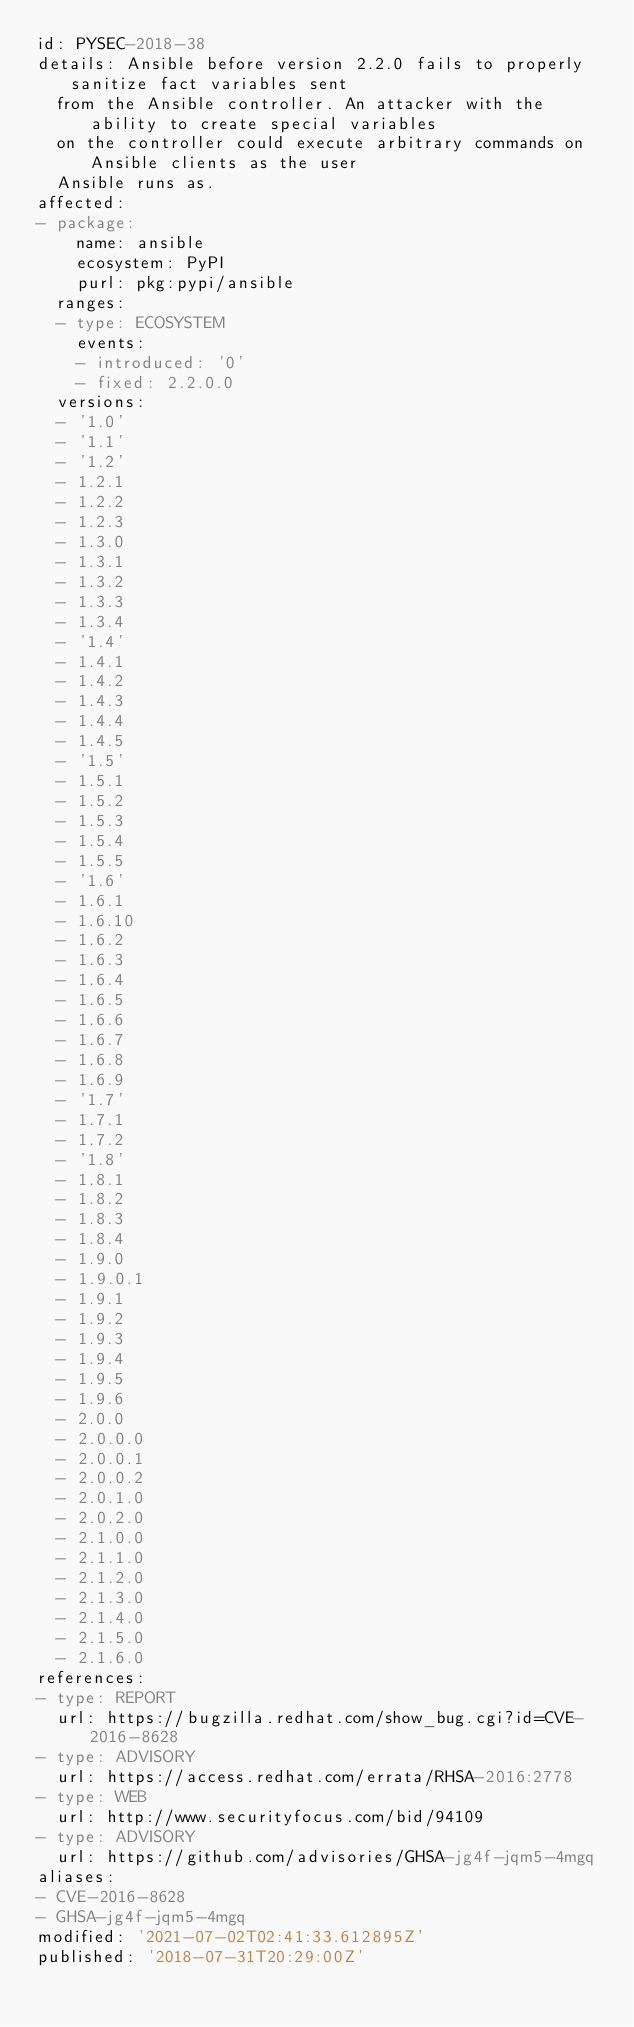<code> <loc_0><loc_0><loc_500><loc_500><_YAML_>id: PYSEC-2018-38
details: Ansible before version 2.2.0 fails to properly sanitize fact variables sent
  from the Ansible controller. An attacker with the ability to create special variables
  on the controller could execute arbitrary commands on Ansible clients as the user
  Ansible runs as.
affected:
- package:
    name: ansible
    ecosystem: PyPI
    purl: pkg:pypi/ansible
  ranges:
  - type: ECOSYSTEM
    events:
    - introduced: '0'
    - fixed: 2.2.0.0
  versions:
  - '1.0'
  - '1.1'
  - '1.2'
  - 1.2.1
  - 1.2.2
  - 1.2.3
  - 1.3.0
  - 1.3.1
  - 1.3.2
  - 1.3.3
  - 1.3.4
  - '1.4'
  - 1.4.1
  - 1.4.2
  - 1.4.3
  - 1.4.4
  - 1.4.5
  - '1.5'
  - 1.5.1
  - 1.5.2
  - 1.5.3
  - 1.5.4
  - 1.5.5
  - '1.6'
  - 1.6.1
  - 1.6.10
  - 1.6.2
  - 1.6.3
  - 1.6.4
  - 1.6.5
  - 1.6.6
  - 1.6.7
  - 1.6.8
  - 1.6.9
  - '1.7'
  - 1.7.1
  - 1.7.2
  - '1.8'
  - 1.8.1
  - 1.8.2
  - 1.8.3
  - 1.8.4
  - 1.9.0
  - 1.9.0.1
  - 1.9.1
  - 1.9.2
  - 1.9.3
  - 1.9.4
  - 1.9.5
  - 1.9.6
  - 2.0.0
  - 2.0.0.0
  - 2.0.0.1
  - 2.0.0.2
  - 2.0.1.0
  - 2.0.2.0
  - 2.1.0.0
  - 2.1.1.0
  - 2.1.2.0
  - 2.1.3.0
  - 2.1.4.0
  - 2.1.5.0
  - 2.1.6.0
references:
- type: REPORT
  url: https://bugzilla.redhat.com/show_bug.cgi?id=CVE-2016-8628
- type: ADVISORY
  url: https://access.redhat.com/errata/RHSA-2016:2778
- type: WEB
  url: http://www.securityfocus.com/bid/94109
- type: ADVISORY
  url: https://github.com/advisories/GHSA-jg4f-jqm5-4mgq
aliases:
- CVE-2016-8628
- GHSA-jg4f-jqm5-4mgq
modified: '2021-07-02T02:41:33.612895Z'
published: '2018-07-31T20:29:00Z'
</code> 